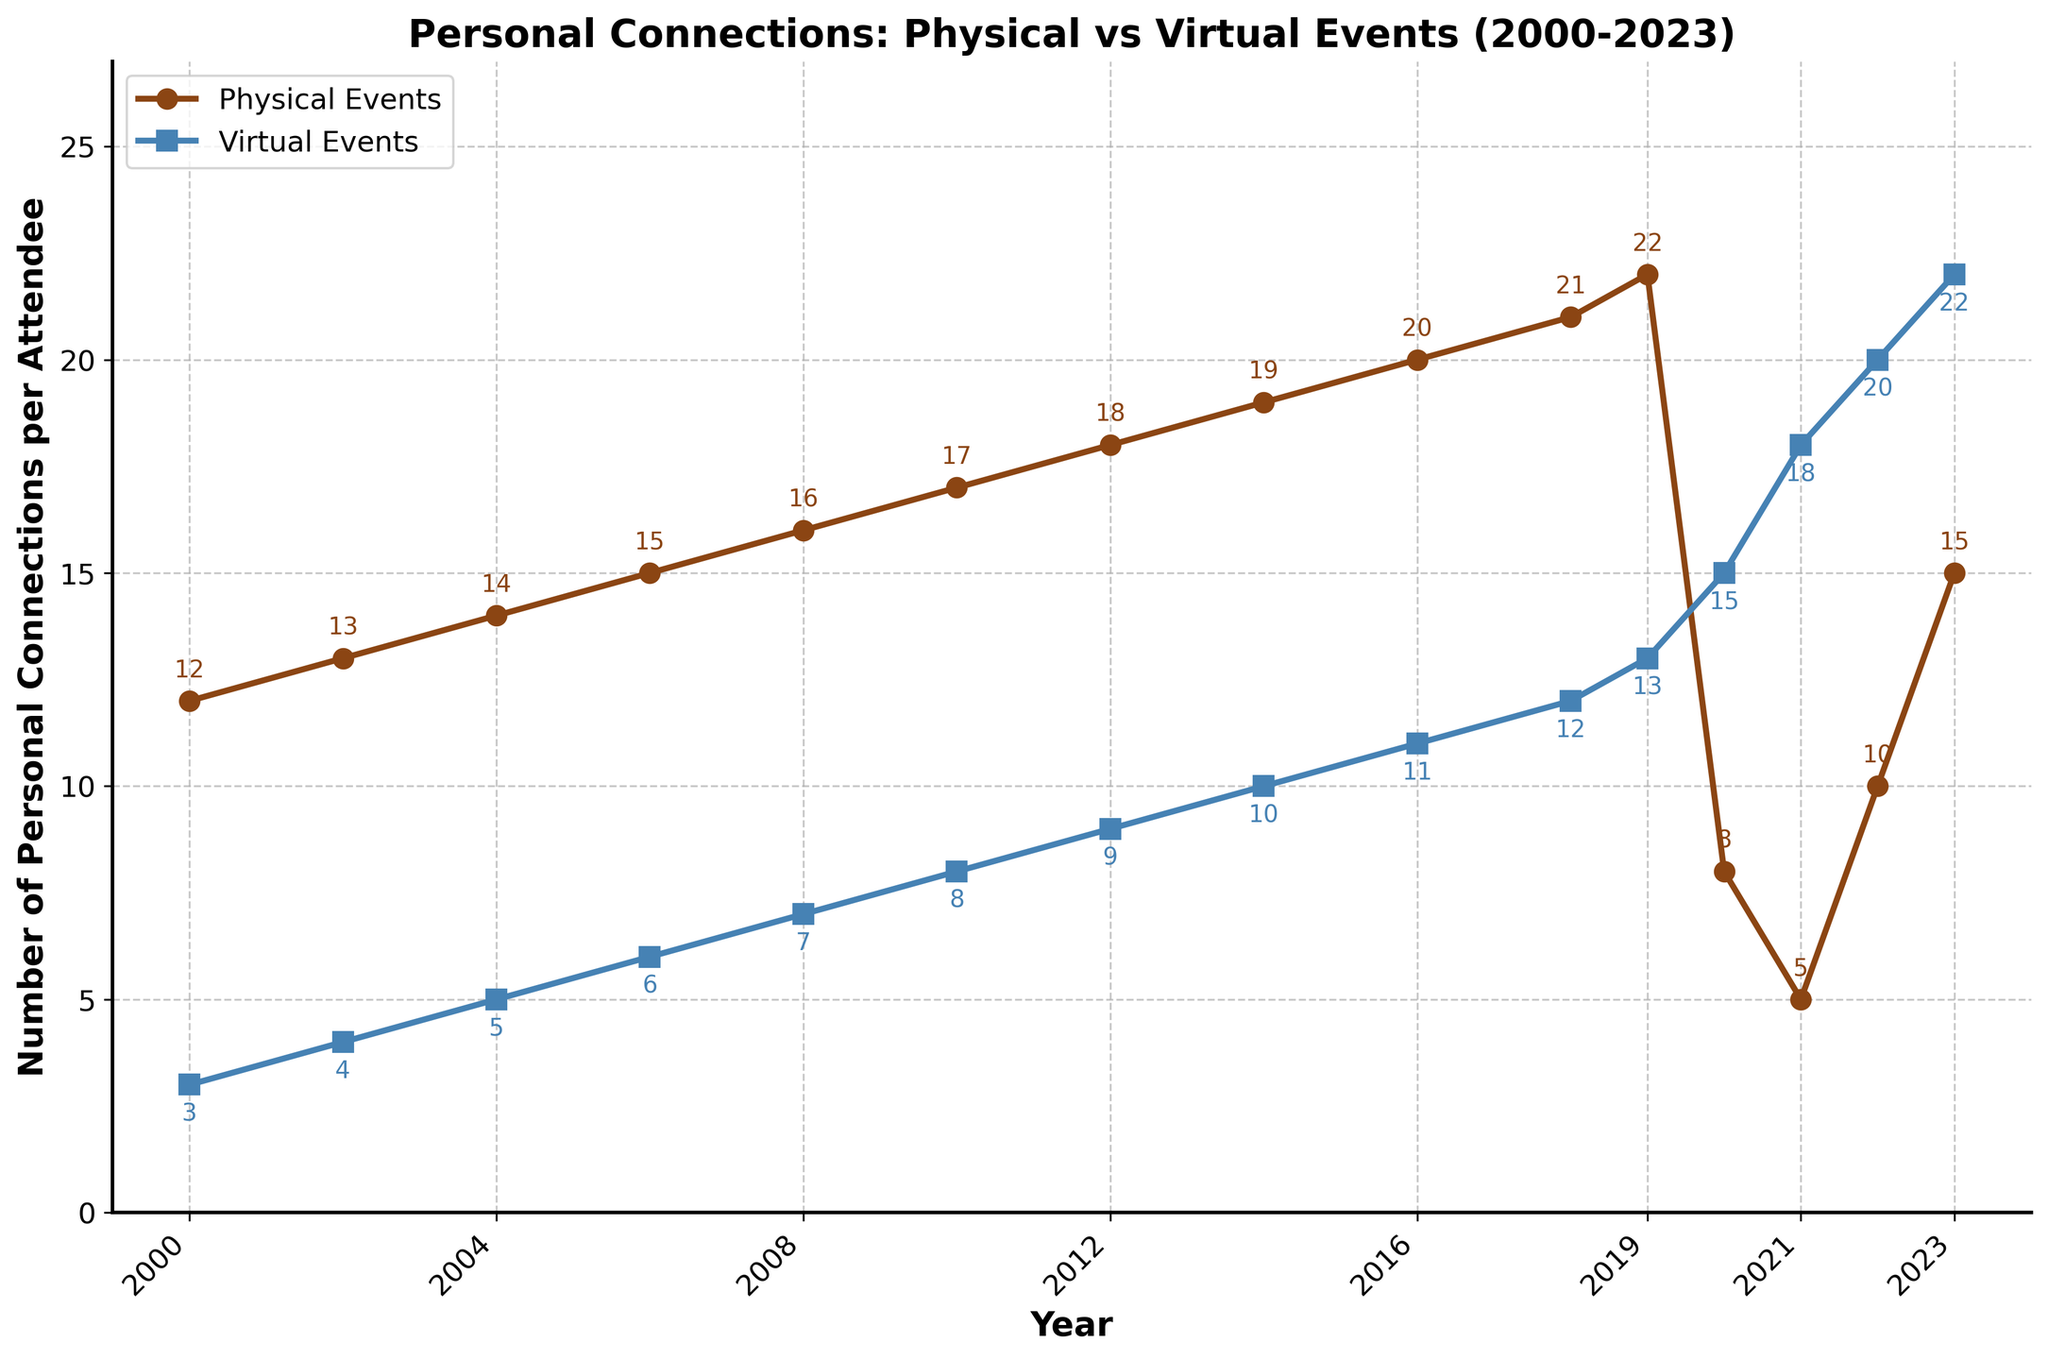What trend can be observed for personal connections at physical events from 2000 to 2019? The number of personal connections made per attendee at physical events shows a steady increase from 12 in 2000 to 22 in 2019.
Answer: Steady increase What happened to the number of personal connections at physical events from 2019 to 2020? The number of personal connections at physical events dropped significantly, from 22 in 2019 to 8 in 2020.
Answer: Dropped significantly Compare the number of personal connections made per attendee at virtual events in 2000 and 2023. In 2000, the number of connections made at virtual events was 3 per attendee, and by 2023, it increased to 22 per attendee.
Answer: Increased from 3 to 22 What is the difference in the number of personal connections made per attendee at physical and virtual events in 2023? In 2023, physical events saw 15 personal connections per attendee, whereas virtual events recorded 22. The difference is 7 connections.
Answer: 7 connections In which year did the personal connections at virtual events surpass those of physical events? Virtual events surpassed physical events in 2020. Virtual events had 15 connections per attendee, while physical events had 8 connections per attendee.
Answer: 2020 What can be inferred from the trend of virtual events from 2000 to 2023? The number of personal connections at virtual events has shown a consistent upward trend from 3 connections per attendee in 2000 to 22 connections per attendee in 2023.
Answer: Consistent upward trend Which year shows the largest disparity between personal connections made at physical and virtual events? In 2012, physical events had 18 connections per attendee, whereas virtual events had 9, resulting in the largest disparity of 9 connections.
Answer: 2012 What is the average number of personal connections made at physical events from 2000 to 2023? Sum the connections from 2000 to 2023 for physical events (12 + 13 + 14 + 15 + 16 + 17 + 18 + 19 + 20 + 21 + 22 + 8 + 5 + 10 + 15 = 225) and divide by the number of years (15). 225 / 15 = 15.
Answer: 15 What is the color of the line representing physical events in the chart? The line representing physical events is colored brown.
Answer: brown How many more personal connections per attendee were made at virtual events than physical events in 2021? In 2021, physical events had 5 connections per attendee and virtual events had 18. The difference is 18 - 5 = 13 connections.
Answer: 13 connections 